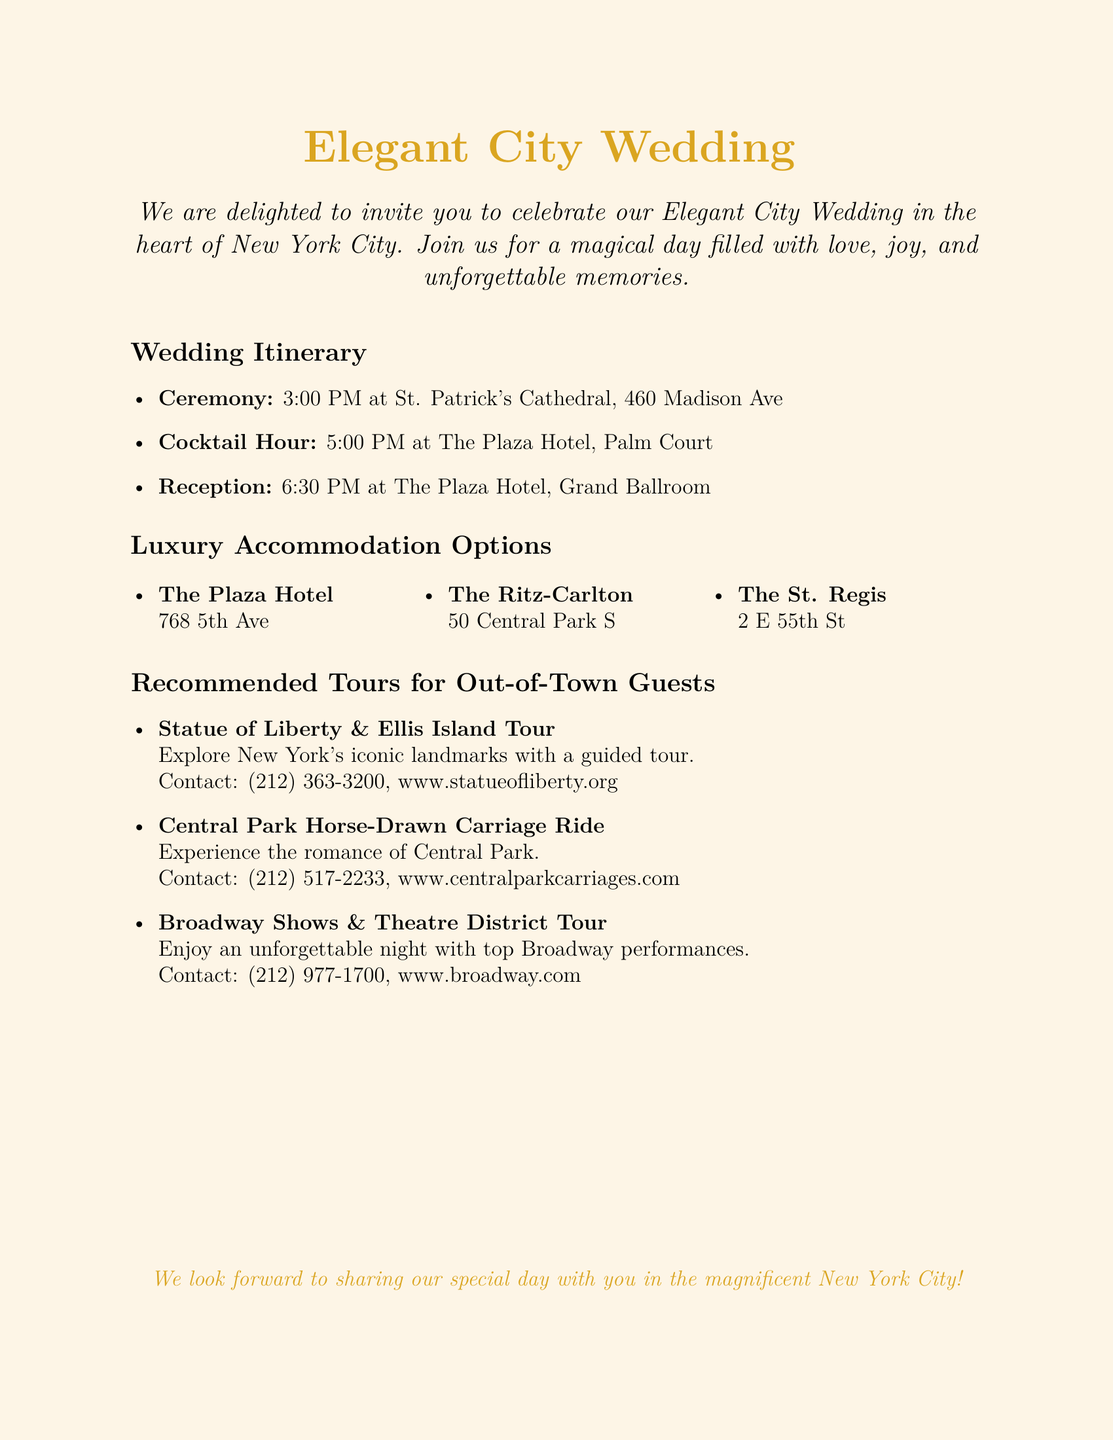What time is the ceremony? The ceremony is scheduled at 3:00 PM, which is listed in the itinerary section.
Answer: 3:00 PM Where will the reception take place? The reception is held at The Plaza Hotel, Grand Ballroom, as mentioned in the itinerary.
Answer: The Plaza Hotel, Grand Ballroom What is one of the luxury accommodation options? One of the luxurious accommodation options is The Plaza Hotel, listed in the accommodation section.
Answer: The Plaza Hotel How many accommodation options are listed? There are three luxury accommodation options provided in the document.
Answer: Three What is the first tour recommended for out-of-town guests? The first recommended tour is the Statue of Liberty & Ellis Island Tour, mentioned in the tours section.
Answer: Statue of Liberty & Ellis Island Tour What type of wedding is being celebrated? The document invites guests to an Elegant City Wedding, as stated in the title.
Answer: Elegant City Wedding What is the contact number for the Broadway Shows tour? The document provides the contact number (212) 977-1700 for the Broadway Shows tour.
Answer: (212) 977-1700 At what time does the cocktail hour begin? The cocktail hour begins at 5:00 PM, which is detailed in the wedding itinerary.
Answer: 5:00 PM Where is the ceremony located? The ceremony is located at St. Patrick's Cathedral, as indicated in the wedding itinerary section.
Answer: St. Patrick's Cathedral 